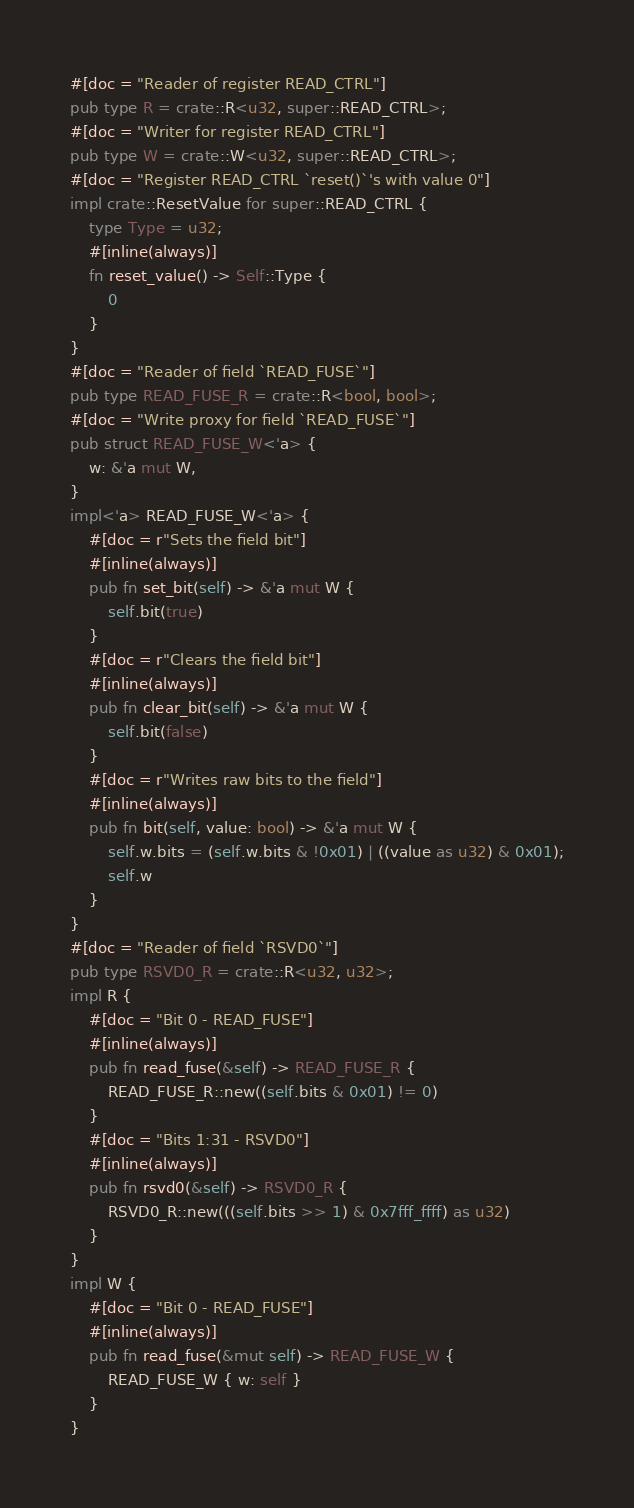<code> <loc_0><loc_0><loc_500><loc_500><_Rust_>#[doc = "Reader of register READ_CTRL"]
pub type R = crate::R<u32, super::READ_CTRL>;
#[doc = "Writer for register READ_CTRL"]
pub type W = crate::W<u32, super::READ_CTRL>;
#[doc = "Register READ_CTRL `reset()`'s with value 0"]
impl crate::ResetValue for super::READ_CTRL {
    type Type = u32;
    #[inline(always)]
    fn reset_value() -> Self::Type {
        0
    }
}
#[doc = "Reader of field `READ_FUSE`"]
pub type READ_FUSE_R = crate::R<bool, bool>;
#[doc = "Write proxy for field `READ_FUSE`"]
pub struct READ_FUSE_W<'a> {
    w: &'a mut W,
}
impl<'a> READ_FUSE_W<'a> {
    #[doc = r"Sets the field bit"]
    #[inline(always)]
    pub fn set_bit(self) -> &'a mut W {
        self.bit(true)
    }
    #[doc = r"Clears the field bit"]
    #[inline(always)]
    pub fn clear_bit(self) -> &'a mut W {
        self.bit(false)
    }
    #[doc = r"Writes raw bits to the field"]
    #[inline(always)]
    pub fn bit(self, value: bool) -> &'a mut W {
        self.w.bits = (self.w.bits & !0x01) | ((value as u32) & 0x01);
        self.w
    }
}
#[doc = "Reader of field `RSVD0`"]
pub type RSVD0_R = crate::R<u32, u32>;
impl R {
    #[doc = "Bit 0 - READ_FUSE"]
    #[inline(always)]
    pub fn read_fuse(&self) -> READ_FUSE_R {
        READ_FUSE_R::new((self.bits & 0x01) != 0)
    }
    #[doc = "Bits 1:31 - RSVD0"]
    #[inline(always)]
    pub fn rsvd0(&self) -> RSVD0_R {
        RSVD0_R::new(((self.bits >> 1) & 0x7fff_ffff) as u32)
    }
}
impl W {
    #[doc = "Bit 0 - READ_FUSE"]
    #[inline(always)]
    pub fn read_fuse(&mut self) -> READ_FUSE_W {
        READ_FUSE_W { w: self }
    }
}
</code> 